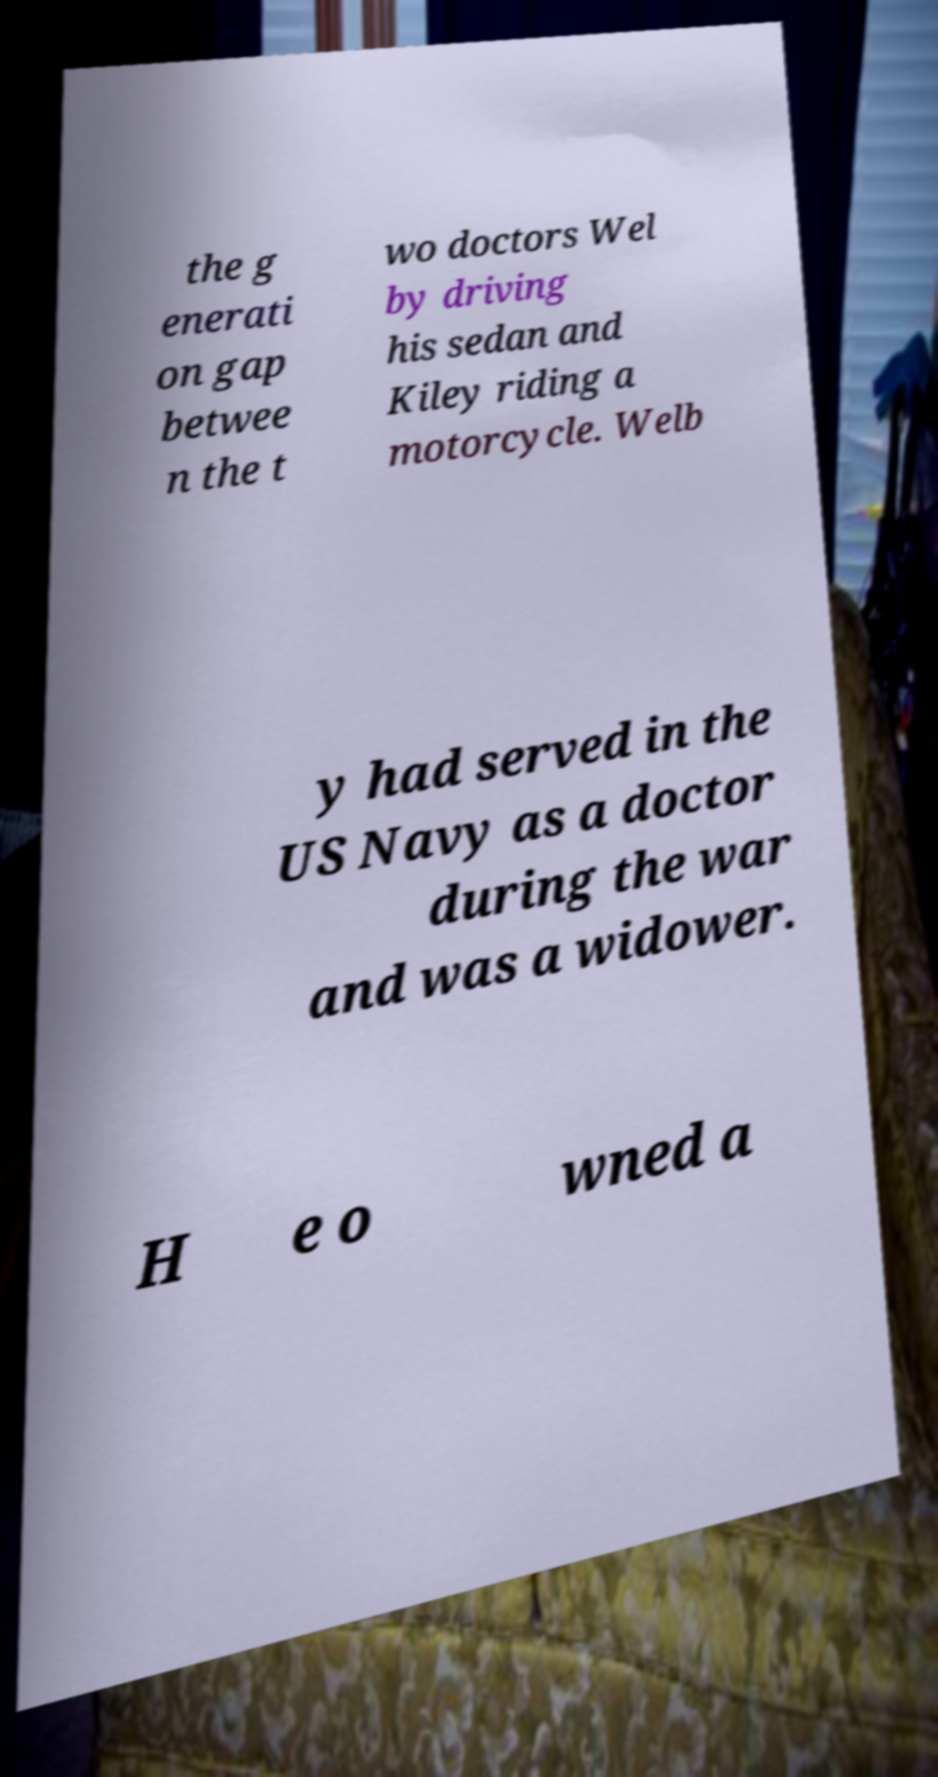Can you accurately transcribe the text from the provided image for me? the g enerati on gap betwee n the t wo doctors Wel by driving his sedan and Kiley riding a motorcycle. Welb y had served in the US Navy as a doctor during the war and was a widower. H e o wned a 